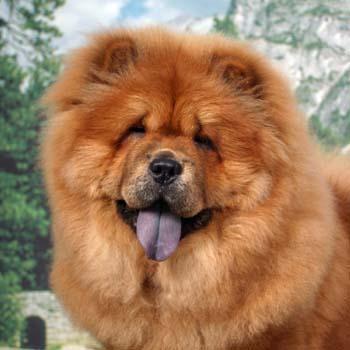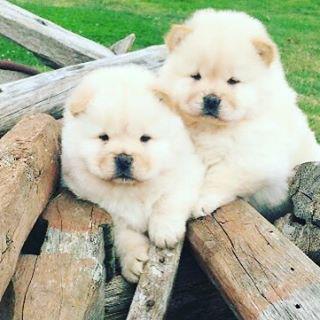The first image is the image on the left, the second image is the image on the right. For the images shown, is this caption "There are three dogs" true? Answer yes or no. Yes. 